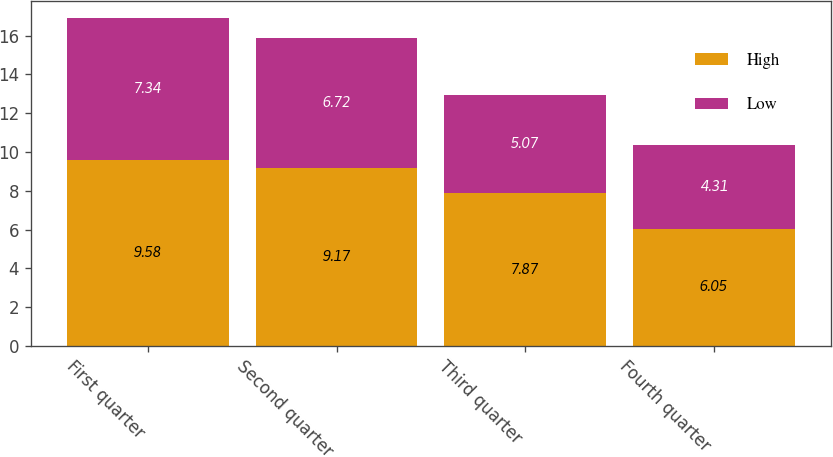Convert chart. <chart><loc_0><loc_0><loc_500><loc_500><stacked_bar_chart><ecel><fcel>First quarter<fcel>Second quarter<fcel>Third quarter<fcel>Fourth quarter<nl><fcel>High<fcel>9.58<fcel>9.17<fcel>7.87<fcel>6.05<nl><fcel>Low<fcel>7.34<fcel>6.72<fcel>5.07<fcel>4.31<nl></chart> 